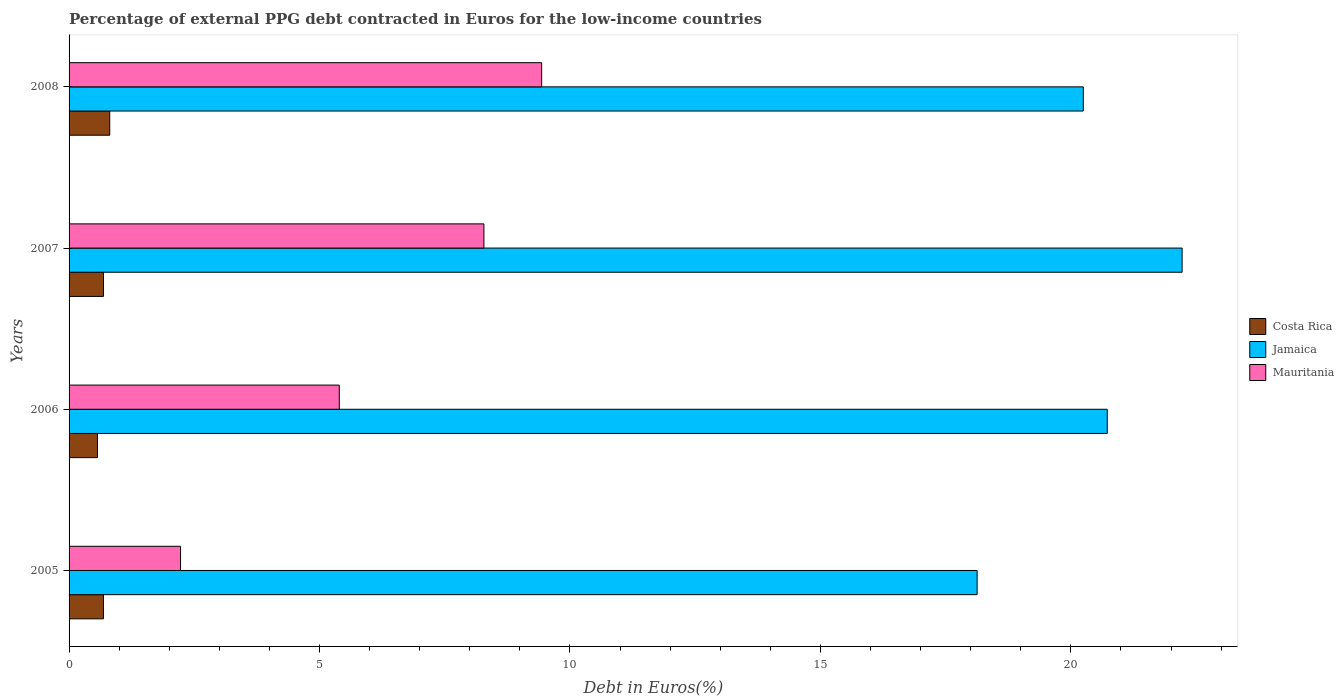How many different coloured bars are there?
Provide a short and direct response. 3. Are the number of bars on each tick of the Y-axis equal?
Offer a very short reply. Yes. How many bars are there on the 4th tick from the top?
Provide a succinct answer. 3. What is the percentage of external PPG debt contracted in Euros in Jamaica in 2007?
Provide a short and direct response. 22.22. Across all years, what is the maximum percentage of external PPG debt contracted in Euros in Costa Rica?
Your response must be concise. 0.81. Across all years, what is the minimum percentage of external PPG debt contracted in Euros in Jamaica?
Offer a very short reply. 18.13. In which year was the percentage of external PPG debt contracted in Euros in Costa Rica minimum?
Offer a terse response. 2006. What is the total percentage of external PPG debt contracted in Euros in Mauritania in the graph?
Provide a short and direct response. 25.34. What is the difference between the percentage of external PPG debt contracted in Euros in Jamaica in 2005 and that in 2007?
Your response must be concise. -4.09. What is the difference between the percentage of external PPG debt contracted in Euros in Mauritania in 2006 and the percentage of external PPG debt contracted in Euros in Jamaica in 2005?
Provide a short and direct response. -12.73. What is the average percentage of external PPG debt contracted in Euros in Mauritania per year?
Provide a succinct answer. 6.33. In the year 2008, what is the difference between the percentage of external PPG debt contracted in Euros in Jamaica and percentage of external PPG debt contracted in Euros in Mauritania?
Provide a short and direct response. 10.81. In how many years, is the percentage of external PPG debt contracted in Euros in Costa Rica greater than 4 %?
Provide a succinct answer. 0. What is the ratio of the percentage of external PPG debt contracted in Euros in Jamaica in 2005 to that in 2006?
Make the answer very short. 0.87. Is the difference between the percentage of external PPG debt contracted in Euros in Jamaica in 2005 and 2006 greater than the difference between the percentage of external PPG debt contracted in Euros in Mauritania in 2005 and 2006?
Ensure brevity in your answer.  Yes. What is the difference between the highest and the second highest percentage of external PPG debt contracted in Euros in Jamaica?
Give a very brief answer. 1.49. What is the difference between the highest and the lowest percentage of external PPG debt contracted in Euros in Costa Rica?
Give a very brief answer. 0.25. In how many years, is the percentage of external PPG debt contracted in Euros in Jamaica greater than the average percentage of external PPG debt contracted in Euros in Jamaica taken over all years?
Provide a succinct answer. 2. What does the 1st bar from the top in 2008 represents?
Your response must be concise. Mauritania. Is it the case that in every year, the sum of the percentage of external PPG debt contracted in Euros in Costa Rica and percentage of external PPG debt contracted in Euros in Mauritania is greater than the percentage of external PPG debt contracted in Euros in Jamaica?
Keep it short and to the point. No. Are all the bars in the graph horizontal?
Provide a succinct answer. Yes. How many years are there in the graph?
Your answer should be compact. 4. Are the values on the major ticks of X-axis written in scientific E-notation?
Your answer should be compact. No. Where does the legend appear in the graph?
Give a very brief answer. Center right. How many legend labels are there?
Provide a short and direct response. 3. How are the legend labels stacked?
Offer a terse response. Vertical. What is the title of the graph?
Ensure brevity in your answer.  Percentage of external PPG debt contracted in Euros for the low-income countries. What is the label or title of the X-axis?
Provide a short and direct response. Debt in Euros(%). What is the label or title of the Y-axis?
Ensure brevity in your answer.  Years. What is the Debt in Euros(%) in Costa Rica in 2005?
Offer a terse response. 0.69. What is the Debt in Euros(%) in Jamaica in 2005?
Your answer should be very brief. 18.13. What is the Debt in Euros(%) of Mauritania in 2005?
Make the answer very short. 2.23. What is the Debt in Euros(%) in Costa Rica in 2006?
Provide a succinct answer. 0.57. What is the Debt in Euros(%) of Jamaica in 2006?
Offer a terse response. 20.73. What is the Debt in Euros(%) of Mauritania in 2006?
Offer a terse response. 5.39. What is the Debt in Euros(%) of Costa Rica in 2007?
Give a very brief answer. 0.69. What is the Debt in Euros(%) of Jamaica in 2007?
Make the answer very short. 22.22. What is the Debt in Euros(%) of Mauritania in 2007?
Give a very brief answer. 8.28. What is the Debt in Euros(%) of Costa Rica in 2008?
Offer a terse response. 0.81. What is the Debt in Euros(%) in Jamaica in 2008?
Your response must be concise. 20.25. What is the Debt in Euros(%) of Mauritania in 2008?
Offer a terse response. 9.43. Across all years, what is the maximum Debt in Euros(%) in Costa Rica?
Make the answer very short. 0.81. Across all years, what is the maximum Debt in Euros(%) of Jamaica?
Ensure brevity in your answer.  22.22. Across all years, what is the maximum Debt in Euros(%) of Mauritania?
Make the answer very short. 9.43. Across all years, what is the minimum Debt in Euros(%) of Costa Rica?
Your answer should be very brief. 0.57. Across all years, what is the minimum Debt in Euros(%) in Jamaica?
Offer a terse response. 18.13. Across all years, what is the minimum Debt in Euros(%) of Mauritania?
Provide a short and direct response. 2.23. What is the total Debt in Euros(%) of Costa Rica in the graph?
Make the answer very short. 2.75. What is the total Debt in Euros(%) of Jamaica in the graph?
Provide a short and direct response. 81.32. What is the total Debt in Euros(%) in Mauritania in the graph?
Offer a very short reply. 25.34. What is the difference between the Debt in Euros(%) of Costa Rica in 2005 and that in 2006?
Your answer should be compact. 0.12. What is the difference between the Debt in Euros(%) of Jamaica in 2005 and that in 2006?
Provide a succinct answer. -2.6. What is the difference between the Debt in Euros(%) in Mauritania in 2005 and that in 2006?
Offer a very short reply. -3.17. What is the difference between the Debt in Euros(%) in Costa Rica in 2005 and that in 2007?
Your response must be concise. -0. What is the difference between the Debt in Euros(%) of Jamaica in 2005 and that in 2007?
Your response must be concise. -4.09. What is the difference between the Debt in Euros(%) of Mauritania in 2005 and that in 2007?
Give a very brief answer. -6.06. What is the difference between the Debt in Euros(%) of Costa Rica in 2005 and that in 2008?
Keep it short and to the point. -0.13. What is the difference between the Debt in Euros(%) in Jamaica in 2005 and that in 2008?
Keep it short and to the point. -2.12. What is the difference between the Debt in Euros(%) of Mauritania in 2005 and that in 2008?
Offer a terse response. -7.21. What is the difference between the Debt in Euros(%) of Costa Rica in 2006 and that in 2007?
Keep it short and to the point. -0.12. What is the difference between the Debt in Euros(%) of Jamaica in 2006 and that in 2007?
Offer a terse response. -1.49. What is the difference between the Debt in Euros(%) in Mauritania in 2006 and that in 2007?
Offer a terse response. -2.89. What is the difference between the Debt in Euros(%) in Costa Rica in 2006 and that in 2008?
Give a very brief answer. -0.25. What is the difference between the Debt in Euros(%) of Jamaica in 2006 and that in 2008?
Keep it short and to the point. 0.48. What is the difference between the Debt in Euros(%) of Mauritania in 2006 and that in 2008?
Make the answer very short. -4.04. What is the difference between the Debt in Euros(%) in Costa Rica in 2007 and that in 2008?
Offer a terse response. -0.12. What is the difference between the Debt in Euros(%) in Jamaica in 2007 and that in 2008?
Provide a short and direct response. 1.97. What is the difference between the Debt in Euros(%) of Mauritania in 2007 and that in 2008?
Give a very brief answer. -1.15. What is the difference between the Debt in Euros(%) in Costa Rica in 2005 and the Debt in Euros(%) in Jamaica in 2006?
Provide a short and direct response. -20.04. What is the difference between the Debt in Euros(%) of Costa Rica in 2005 and the Debt in Euros(%) of Mauritania in 2006?
Provide a short and direct response. -4.71. What is the difference between the Debt in Euros(%) in Jamaica in 2005 and the Debt in Euros(%) in Mauritania in 2006?
Provide a short and direct response. 12.73. What is the difference between the Debt in Euros(%) of Costa Rica in 2005 and the Debt in Euros(%) of Jamaica in 2007?
Provide a short and direct response. -21.53. What is the difference between the Debt in Euros(%) in Costa Rica in 2005 and the Debt in Euros(%) in Mauritania in 2007?
Your response must be concise. -7.6. What is the difference between the Debt in Euros(%) of Jamaica in 2005 and the Debt in Euros(%) of Mauritania in 2007?
Make the answer very short. 9.85. What is the difference between the Debt in Euros(%) of Costa Rica in 2005 and the Debt in Euros(%) of Jamaica in 2008?
Make the answer very short. -19.56. What is the difference between the Debt in Euros(%) in Costa Rica in 2005 and the Debt in Euros(%) in Mauritania in 2008?
Offer a terse response. -8.75. What is the difference between the Debt in Euros(%) of Jamaica in 2005 and the Debt in Euros(%) of Mauritania in 2008?
Provide a short and direct response. 8.69. What is the difference between the Debt in Euros(%) in Costa Rica in 2006 and the Debt in Euros(%) in Jamaica in 2007?
Your answer should be very brief. -21.65. What is the difference between the Debt in Euros(%) in Costa Rica in 2006 and the Debt in Euros(%) in Mauritania in 2007?
Your response must be concise. -7.72. What is the difference between the Debt in Euros(%) in Jamaica in 2006 and the Debt in Euros(%) in Mauritania in 2007?
Offer a terse response. 12.44. What is the difference between the Debt in Euros(%) of Costa Rica in 2006 and the Debt in Euros(%) of Jamaica in 2008?
Give a very brief answer. -19.68. What is the difference between the Debt in Euros(%) of Costa Rica in 2006 and the Debt in Euros(%) of Mauritania in 2008?
Provide a succinct answer. -8.87. What is the difference between the Debt in Euros(%) in Jamaica in 2006 and the Debt in Euros(%) in Mauritania in 2008?
Provide a short and direct response. 11.29. What is the difference between the Debt in Euros(%) of Costa Rica in 2007 and the Debt in Euros(%) of Jamaica in 2008?
Your response must be concise. -19.56. What is the difference between the Debt in Euros(%) in Costa Rica in 2007 and the Debt in Euros(%) in Mauritania in 2008?
Make the answer very short. -8.75. What is the difference between the Debt in Euros(%) of Jamaica in 2007 and the Debt in Euros(%) of Mauritania in 2008?
Offer a very short reply. 12.79. What is the average Debt in Euros(%) of Costa Rica per year?
Your answer should be very brief. 0.69. What is the average Debt in Euros(%) of Jamaica per year?
Keep it short and to the point. 20.33. What is the average Debt in Euros(%) of Mauritania per year?
Ensure brevity in your answer.  6.33. In the year 2005, what is the difference between the Debt in Euros(%) in Costa Rica and Debt in Euros(%) in Jamaica?
Give a very brief answer. -17.44. In the year 2005, what is the difference between the Debt in Euros(%) in Costa Rica and Debt in Euros(%) in Mauritania?
Provide a succinct answer. -1.54. In the year 2005, what is the difference between the Debt in Euros(%) of Jamaica and Debt in Euros(%) of Mauritania?
Your answer should be very brief. 15.9. In the year 2006, what is the difference between the Debt in Euros(%) of Costa Rica and Debt in Euros(%) of Jamaica?
Ensure brevity in your answer.  -20.16. In the year 2006, what is the difference between the Debt in Euros(%) in Costa Rica and Debt in Euros(%) in Mauritania?
Provide a succinct answer. -4.83. In the year 2006, what is the difference between the Debt in Euros(%) in Jamaica and Debt in Euros(%) in Mauritania?
Offer a very short reply. 15.33. In the year 2007, what is the difference between the Debt in Euros(%) in Costa Rica and Debt in Euros(%) in Jamaica?
Make the answer very short. -21.53. In the year 2007, what is the difference between the Debt in Euros(%) of Costa Rica and Debt in Euros(%) of Mauritania?
Keep it short and to the point. -7.59. In the year 2007, what is the difference between the Debt in Euros(%) in Jamaica and Debt in Euros(%) in Mauritania?
Make the answer very short. 13.94. In the year 2008, what is the difference between the Debt in Euros(%) of Costa Rica and Debt in Euros(%) of Jamaica?
Provide a succinct answer. -19.44. In the year 2008, what is the difference between the Debt in Euros(%) of Costa Rica and Debt in Euros(%) of Mauritania?
Provide a succinct answer. -8.62. In the year 2008, what is the difference between the Debt in Euros(%) in Jamaica and Debt in Euros(%) in Mauritania?
Your response must be concise. 10.81. What is the ratio of the Debt in Euros(%) of Costa Rica in 2005 to that in 2006?
Your response must be concise. 1.21. What is the ratio of the Debt in Euros(%) in Jamaica in 2005 to that in 2006?
Give a very brief answer. 0.87. What is the ratio of the Debt in Euros(%) of Mauritania in 2005 to that in 2006?
Your answer should be compact. 0.41. What is the ratio of the Debt in Euros(%) in Jamaica in 2005 to that in 2007?
Your answer should be compact. 0.82. What is the ratio of the Debt in Euros(%) in Mauritania in 2005 to that in 2007?
Your response must be concise. 0.27. What is the ratio of the Debt in Euros(%) in Costa Rica in 2005 to that in 2008?
Ensure brevity in your answer.  0.84. What is the ratio of the Debt in Euros(%) of Jamaica in 2005 to that in 2008?
Provide a short and direct response. 0.9. What is the ratio of the Debt in Euros(%) of Mauritania in 2005 to that in 2008?
Your answer should be very brief. 0.24. What is the ratio of the Debt in Euros(%) in Costa Rica in 2006 to that in 2007?
Keep it short and to the point. 0.82. What is the ratio of the Debt in Euros(%) of Jamaica in 2006 to that in 2007?
Give a very brief answer. 0.93. What is the ratio of the Debt in Euros(%) in Mauritania in 2006 to that in 2007?
Provide a succinct answer. 0.65. What is the ratio of the Debt in Euros(%) of Costa Rica in 2006 to that in 2008?
Make the answer very short. 0.7. What is the ratio of the Debt in Euros(%) in Jamaica in 2006 to that in 2008?
Provide a succinct answer. 1.02. What is the ratio of the Debt in Euros(%) of Mauritania in 2006 to that in 2008?
Give a very brief answer. 0.57. What is the ratio of the Debt in Euros(%) of Costa Rica in 2007 to that in 2008?
Provide a short and direct response. 0.85. What is the ratio of the Debt in Euros(%) in Jamaica in 2007 to that in 2008?
Ensure brevity in your answer.  1.1. What is the ratio of the Debt in Euros(%) of Mauritania in 2007 to that in 2008?
Give a very brief answer. 0.88. What is the difference between the highest and the second highest Debt in Euros(%) in Costa Rica?
Make the answer very short. 0.12. What is the difference between the highest and the second highest Debt in Euros(%) of Jamaica?
Provide a short and direct response. 1.49. What is the difference between the highest and the second highest Debt in Euros(%) in Mauritania?
Keep it short and to the point. 1.15. What is the difference between the highest and the lowest Debt in Euros(%) of Costa Rica?
Offer a terse response. 0.25. What is the difference between the highest and the lowest Debt in Euros(%) in Jamaica?
Your answer should be compact. 4.09. What is the difference between the highest and the lowest Debt in Euros(%) in Mauritania?
Your response must be concise. 7.21. 